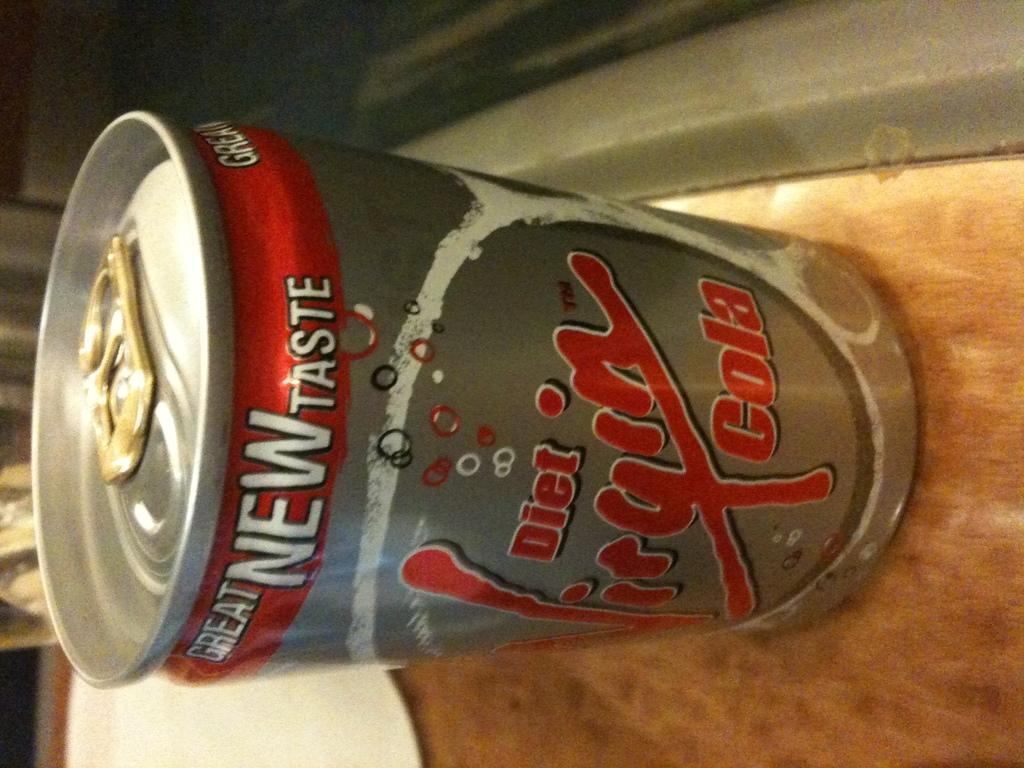<image>
Share a concise interpretation of the image provided. A gray, white and red diet vigin cola can. 